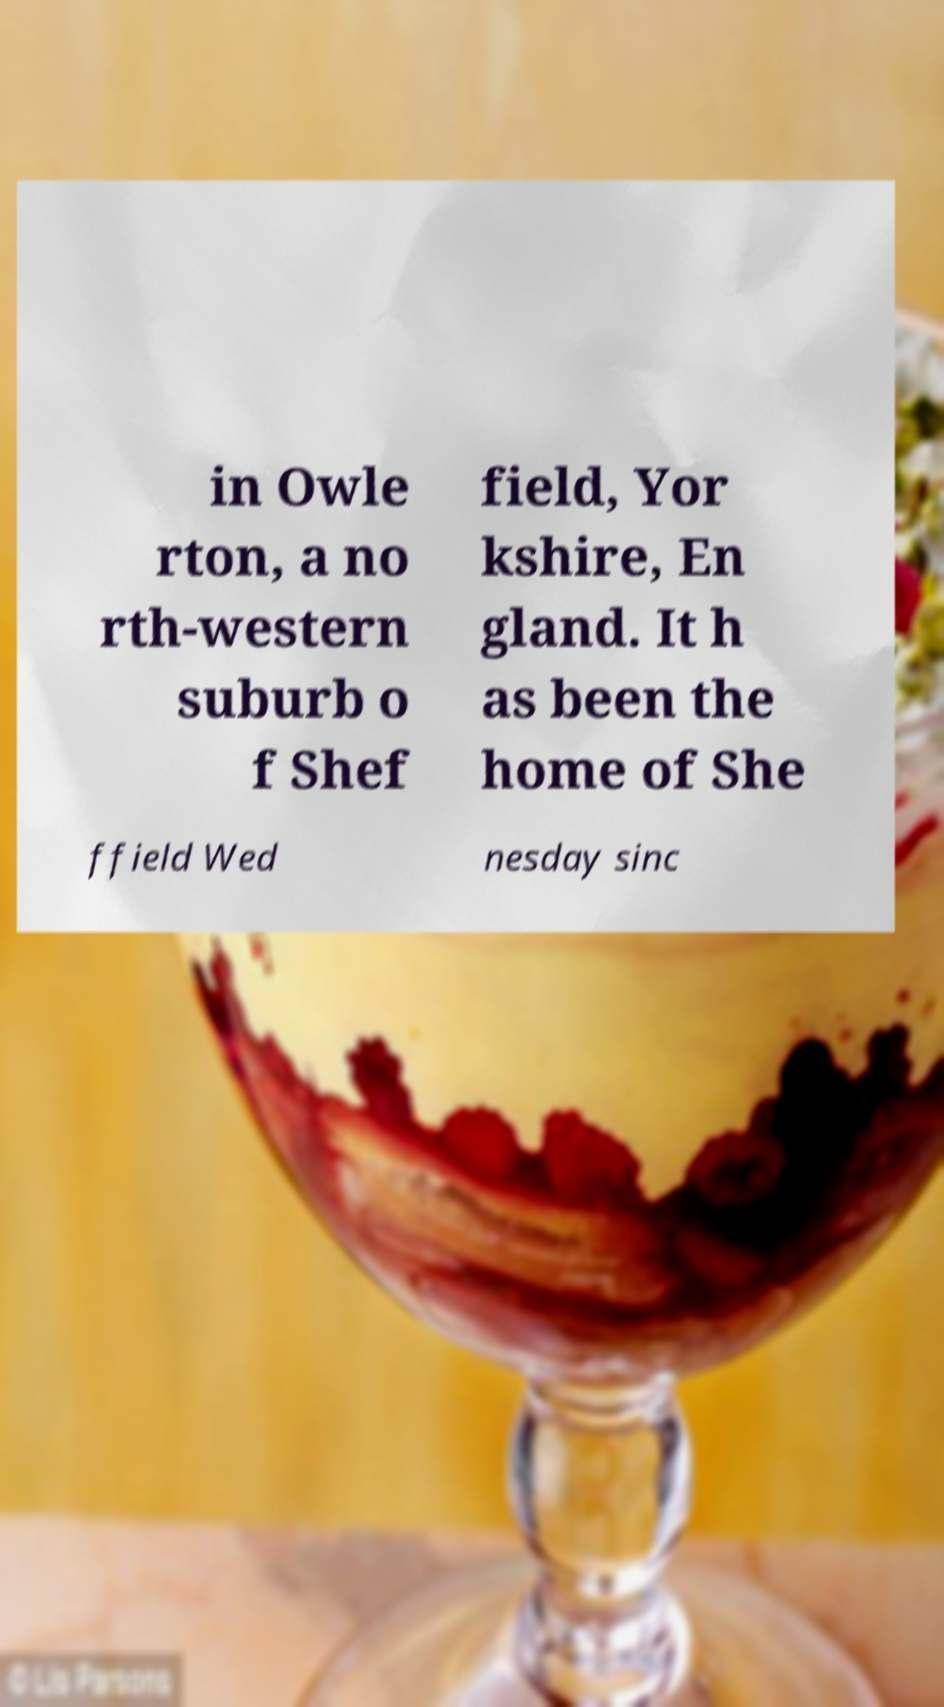There's text embedded in this image that I need extracted. Can you transcribe it verbatim? in Owle rton, a no rth-western suburb o f Shef field, Yor kshire, En gland. It h as been the home of She ffield Wed nesday sinc 